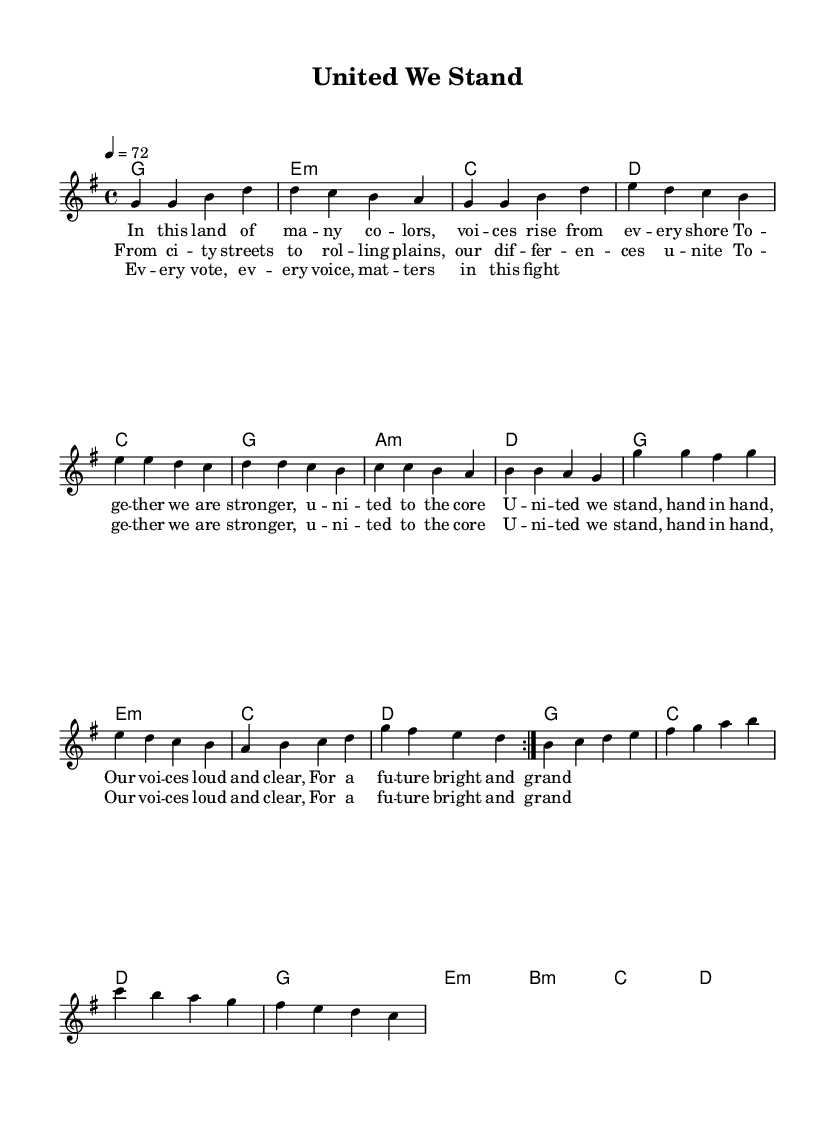What is the key signature of this music? The key signature is indicated at the beginning of the piece. It shows one sharp, which corresponds to the key of G major.
Answer: G major What is the time signature of this music? The time signature is indicated at the beginning of the sheet music, showing a "4/4" sign which means there are four beats per measure.
Answer: 4/4 What is the tempo marking for this piece? The tempo is indicated as "4 = 72," which means there should be 72 beats per minute in a quarter note.
Answer: 72 How many measures are in the verse section? The verse section consists of two repeated segments of four measures each, resulting in a total of 8 measures in the verse.
Answer: 8 What is the main lyrical theme of the song? The lyrics emphasize unity, diversity, and empowerment, showcasing voices coming together for a brighter future.
Answer: Unity and empowerment Which chord follows the bridge in this song? The chords are indicated in the harmonies; after the bridge section, the next chord is 'c' leading back into the main structure of the song.
Answer: c What type of musical structure is used in this piece? The song follows a common pop ballad structure with verses, a pre-chorus, a chorus, and a bridge, creating a relatable and emotional narrative.
Answer: Verse-chorus-bridge structure 